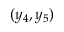<formula> <loc_0><loc_0><loc_500><loc_500>( y _ { 4 } , y _ { 5 } )</formula> 